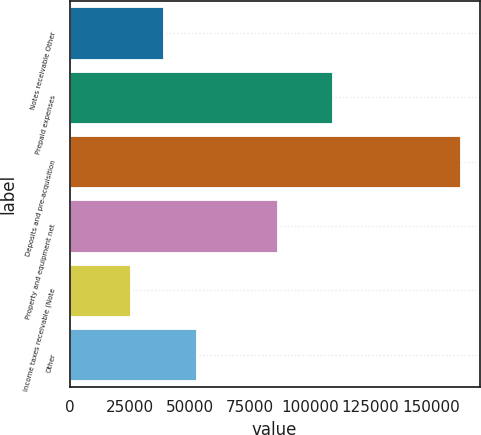<chart> <loc_0><loc_0><loc_500><loc_500><bar_chart><fcel>Notes receivable Other<fcel>Prepaid expenses<fcel>Deposits and pre-acquisition<fcel>Property and equipment net<fcel>Income taxes receivable (Note<fcel>Other<nl><fcel>38783.9<fcel>109113<fcel>162119<fcel>86312<fcel>25080<fcel>52487.8<nl></chart> 